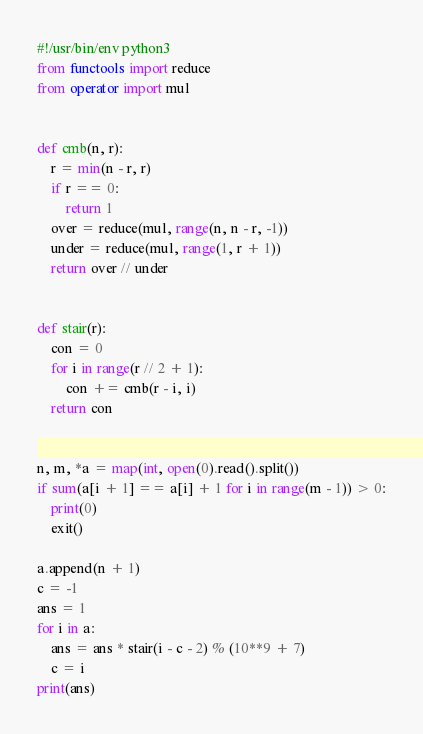Convert code to text. <code><loc_0><loc_0><loc_500><loc_500><_Python_>#!/usr/bin/env python3
from functools import reduce
from operator import mul


def cmb(n, r):
    r = min(n - r, r)
    if r == 0:
        return 1
    over = reduce(mul, range(n, n - r, -1))
    under = reduce(mul, range(1, r + 1))
    return over // under


def stair(r):
    con = 0
    for i in range(r // 2 + 1):
        con += cmb(r - i, i)
    return con


n, m, *a = map(int, open(0).read().split())
if sum(a[i + 1] == a[i] + 1 for i in range(m - 1)) > 0:
    print(0)
    exit()

a.append(n + 1)
c = -1
ans = 1
for i in a:
    ans = ans * stair(i - c - 2) % (10**9 + 7)
    c = i
print(ans)
</code> 